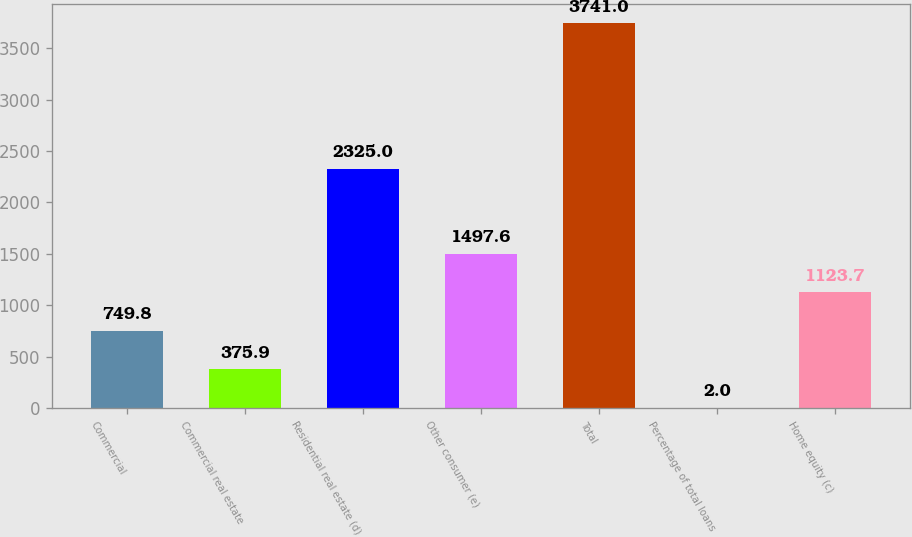Convert chart to OTSL. <chart><loc_0><loc_0><loc_500><loc_500><bar_chart><fcel>Commercial<fcel>Commercial real estate<fcel>Residential real estate (d)<fcel>Other consumer (e)<fcel>Total<fcel>Percentage of total loans<fcel>Home equity (c)<nl><fcel>749.8<fcel>375.9<fcel>2325<fcel>1497.6<fcel>3741<fcel>2<fcel>1123.7<nl></chart> 